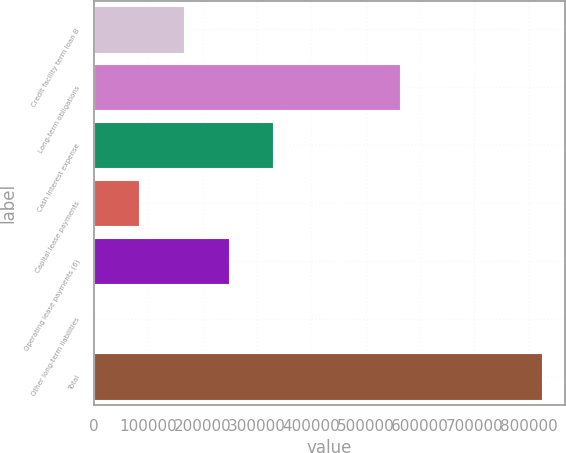Convert chart. <chart><loc_0><loc_0><loc_500><loc_500><bar_chart><fcel>Credit facility term loan B<fcel>Long-term obligations<fcel>Cash interest expense<fcel>Capital lease payments<fcel>Operating lease payments (6)<fcel>Other long-term liabilities<fcel>Total<nl><fcel>165169<fcel>562251<fcel>330116<fcel>82696.2<fcel>247643<fcel>223<fcel>824955<nl></chart> 